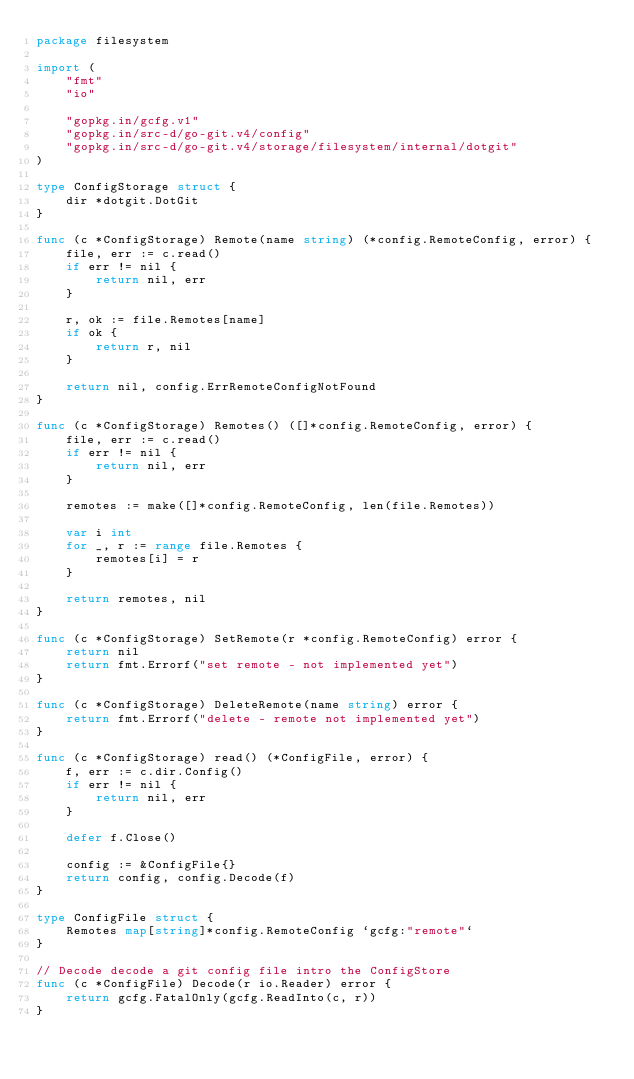<code> <loc_0><loc_0><loc_500><loc_500><_Go_>package filesystem

import (
	"fmt"
	"io"

	"gopkg.in/gcfg.v1"
	"gopkg.in/src-d/go-git.v4/config"
	"gopkg.in/src-d/go-git.v4/storage/filesystem/internal/dotgit"
)

type ConfigStorage struct {
	dir *dotgit.DotGit
}

func (c *ConfigStorage) Remote(name string) (*config.RemoteConfig, error) {
	file, err := c.read()
	if err != nil {
		return nil, err
	}

	r, ok := file.Remotes[name]
	if ok {
		return r, nil
	}

	return nil, config.ErrRemoteConfigNotFound
}

func (c *ConfigStorage) Remotes() ([]*config.RemoteConfig, error) {
	file, err := c.read()
	if err != nil {
		return nil, err
	}

	remotes := make([]*config.RemoteConfig, len(file.Remotes))

	var i int
	for _, r := range file.Remotes {
		remotes[i] = r
	}

	return remotes, nil
}

func (c *ConfigStorage) SetRemote(r *config.RemoteConfig) error {
	return nil
	return fmt.Errorf("set remote - not implemented yet")
}

func (c *ConfigStorage) DeleteRemote(name string) error {
	return fmt.Errorf("delete - remote not implemented yet")
}

func (c *ConfigStorage) read() (*ConfigFile, error) {
	f, err := c.dir.Config()
	if err != nil {
		return nil, err
	}

	defer f.Close()

	config := &ConfigFile{}
	return config, config.Decode(f)
}

type ConfigFile struct {
	Remotes map[string]*config.RemoteConfig `gcfg:"remote"`
}

// Decode decode a git config file intro the ConfigStore
func (c *ConfigFile) Decode(r io.Reader) error {
	return gcfg.FatalOnly(gcfg.ReadInto(c, r))
}
</code> 